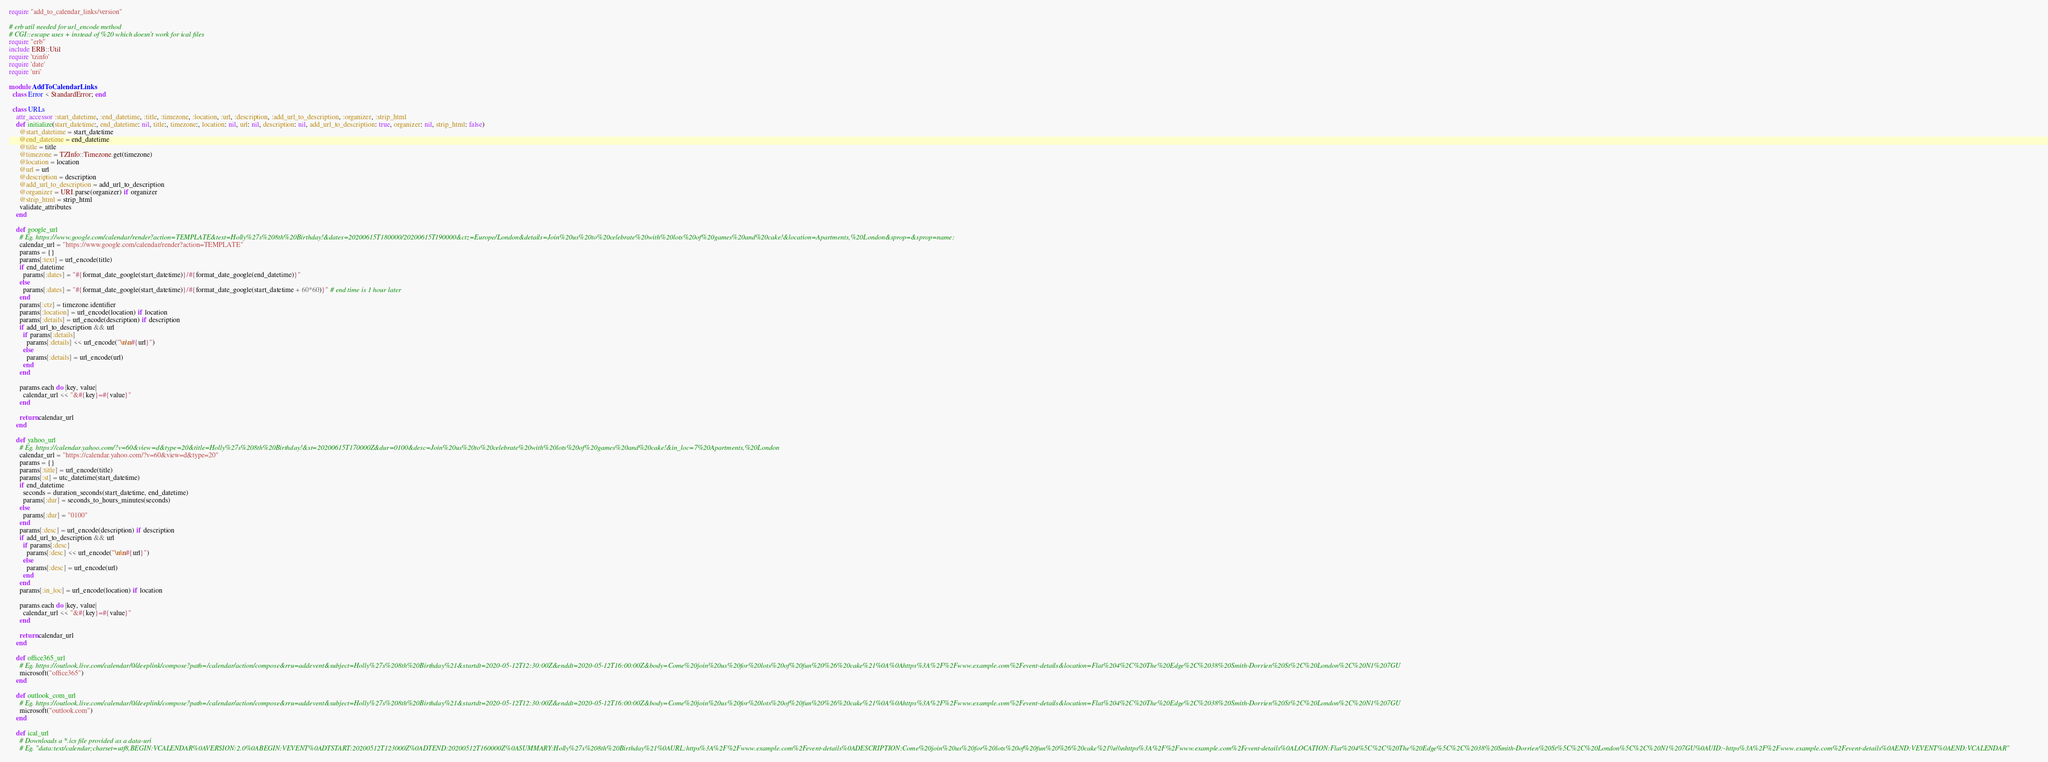Convert code to text. <code><loc_0><loc_0><loc_500><loc_500><_Ruby_>require "add_to_calendar_links/version"

# erb util needed for url_encode method
# CGI::escape uses + instead of %20 which doesn't work for ical files
require "erb"
include ERB::Util
require 'tzinfo'
require 'date'
require 'uri'

module AddToCalendarLinks
  class Error < StandardError; end
  
  class URLs
    attr_accessor :start_datetime, :end_datetime, :title, :timezone, :location, :url, :description, :add_url_to_description, :organizer, :strip_html
    def initialize(start_datetime:, end_datetime: nil, title:, timezone:, location: nil, url: nil, description: nil, add_url_to_description: true, organizer: nil, strip_html: false)
      @start_datetime = start_datetime
      @end_datetime = end_datetime
      @title = title
      @timezone = TZInfo::Timezone.get(timezone)
      @location = location
      @url = url
      @description = description
      @add_url_to_description = add_url_to_description
      @organizer = URI.parse(organizer) if organizer
      @strip_html = strip_html
      validate_attributes
    end
  
    def google_url
      # Eg. https://www.google.com/calendar/render?action=TEMPLATE&text=Holly%27s%208th%20Birthday!&dates=20200615T180000/20200615T190000&ctz=Europe/London&details=Join%20us%20to%20celebrate%20with%20lots%20of%20games%20and%20cake!&location=Apartments,%20London&sprop=&sprop=name:
      calendar_url = "https://www.google.com/calendar/render?action=TEMPLATE"
      params = {}
      params[:text] = url_encode(title)
      if end_datetime
        params[:dates] = "#{format_date_google(start_datetime)}/#{format_date_google(end_datetime)}"
      else
        params[:dates] = "#{format_date_google(start_datetime)}/#{format_date_google(start_datetime + 60*60)}" # end time is 1 hour later
      end
      params[:ctz] = timezone.identifier
      params[:location] = url_encode(location) if location
      params[:details] = url_encode(description) if description
      if add_url_to_description && url
        if params[:details]
          params[:details] << url_encode("\n\n#{url}")
        else
          params[:details] = url_encode(url)
        end
      end
  
      params.each do |key, value|
        calendar_url << "&#{key}=#{value}"
      end
  
      return calendar_url
    end

    def yahoo_url
      # Eg. https://calendar.yahoo.com/?v=60&view=d&type=20&title=Holly%27s%208th%20Birthday!&st=20200615T170000Z&dur=0100&desc=Join%20us%20to%20celebrate%20with%20lots%20of%20games%20and%20cake!&in_loc=7%20Apartments,%20London
      calendar_url = "https://calendar.yahoo.com/?v=60&view=d&type=20"
      params = {}
      params[:title] = url_encode(title)
      params[:st] = utc_datetime(start_datetime)
      if end_datetime
        seconds = duration_seconds(start_datetime, end_datetime)
        params[:dur] = seconds_to_hours_minutes(seconds)
      else
        params[:dur] = "0100" 
      end
      params[:desc] = url_encode(description) if description
      if add_url_to_description && url
        if params[:desc]
          params[:desc] << url_encode("\n\n#{url}")
        else
          params[:desc] = url_encode(url)
        end
      end
      params[:in_loc] = url_encode(location) if location

      params.each do |key, value|
        calendar_url << "&#{key}=#{value}"
      end
  
      return calendar_url
    end

    def office365_url
      # Eg. https://outlook.live.com/calendar/0/deeplink/compose?path=/calendar/action/compose&rru=addevent&subject=Holly%27s%208th%20Birthday%21&startdt=2020-05-12T12:30:00Z&enddt=2020-05-12T16:00:00Z&body=Come%20join%20us%20for%20lots%20of%20fun%20%26%20cake%21%0A%0Ahttps%3A%2F%2Fwww.example.com%2Fevent-details&location=Flat%204%2C%20The%20Edge%2C%2038%20Smith-Dorrien%20St%2C%20London%2C%20N1%207GU
      microsoft("office365")
    end
    
    def outlook_com_url
      # Eg. https://outlook.live.com/calendar/0/deeplink/compose?path=/calendar/action/compose&rru=addevent&subject=Holly%27s%208th%20Birthday%21&startdt=2020-05-12T12:30:00Z&enddt=2020-05-12T16:00:00Z&body=Come%20join%20us%20for%20lots%20of%20fun%20%26%20cake%21%0A%0Ahttps%3A%2F%2Fwww.example.com%2Fevent-details&location=Flat%204%2C%20The%20Edge%2C%2038%20Smith-Dorrien%20St%2C%20London%2C%20N1%207GU
      microsoft("outlook.com")
    end

    def ical_url
      # Downloads a *.ics file provided as a data-uri
      # Eg. "data:text/calendar;charset=utf8,BEGIN:VCALENDAR%0AVERSION:2.0%0ABEGIN:VEVENT%0ADTSTART:20200512T123000Z%0ADTEND:20200512T160000Z%0ASUMMARY:Holly%27s%208th%20Birthday%21%0AURL:https%3A%2F%2Fwww.example.com%2Fevent-details%0ADESCRIPTION:Come%20join%20us%20for%20lots%20of%20fun%20%26%20cake%21\\n\\nhttps%3A%2F%2Fwww.example.com%2Fevent-details%0ALOCATION:Flat%204%5C%2C%20The%20Edge%5C%2C%2038%20Smith-Dorrien%20St%5C%2C%20London%5C%2C%20N1%207GU%0AUID:-https%3A%2F%2Fwww.example.com%2Fevent-details%0AEND:VEVENT%0AEND:VCALENDAR"</code> 